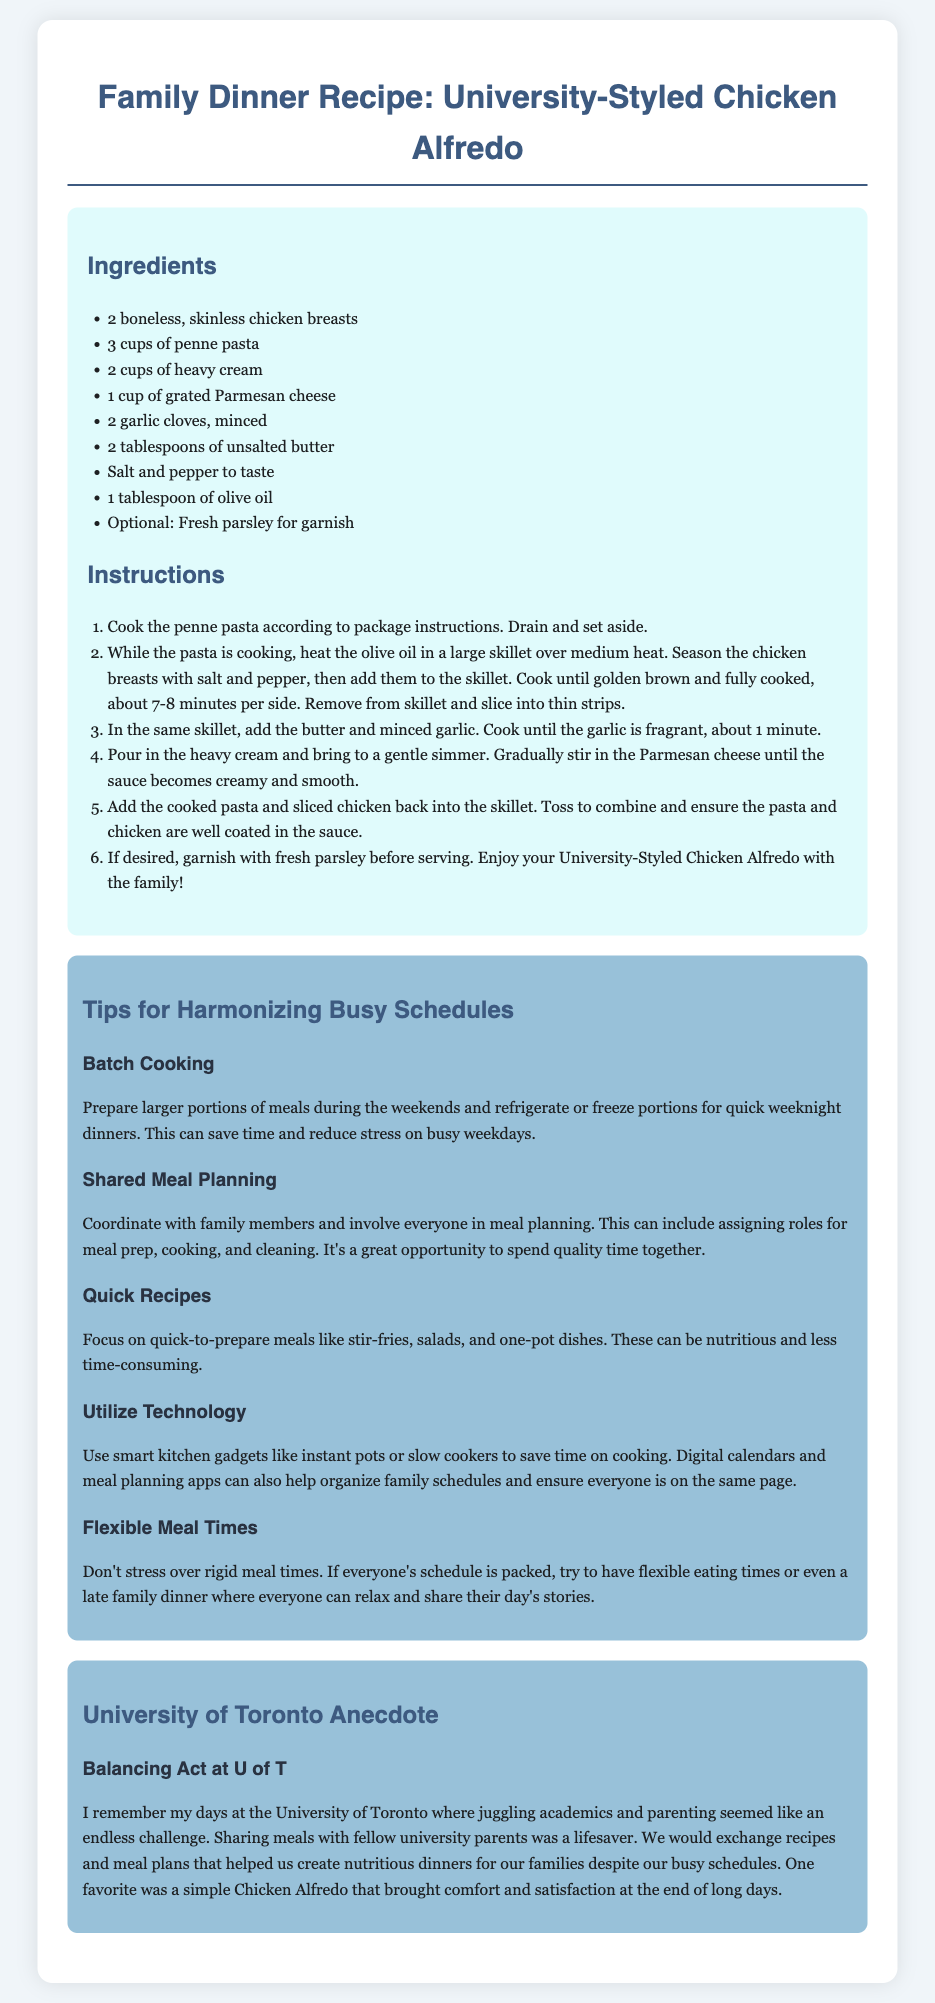What are the main ingredients in the recipe? The main ingredients can be found in the ingredients section and include chicken breasts, penne pasta, heavy cream, Parmesan cheese, garlic, butter, salt, pepper, olive oil, and parsley.
Answer: chicken breasts, penne pasta, heavy cream, Parmesan cheese, garlic, butter, salt, pepper, olive oil, parsley How long does the chicken need to cook? The cooking time for the chicken can be found in the instructions, which states it takes about 7-8 minutes per side.
Answer: 7-8 minutes What is a tip for busy schedules? A tip for busy schedules can be located in the tips section, which includes advice like batch cooking, shared meal planning, or quick recipes.
Answer: batch cooking What type of recipe is featured in this document? The type of recipe can be identified in the title of the document, which is specific to a family dinner recipe.
Answer: chicken alfredo What was a personal challenge mentioned in the anecdote? The personal challenge can be inferred from the anecdote, which touches upon juggling academics and parenting.
Answer: juggling academics and parenting 